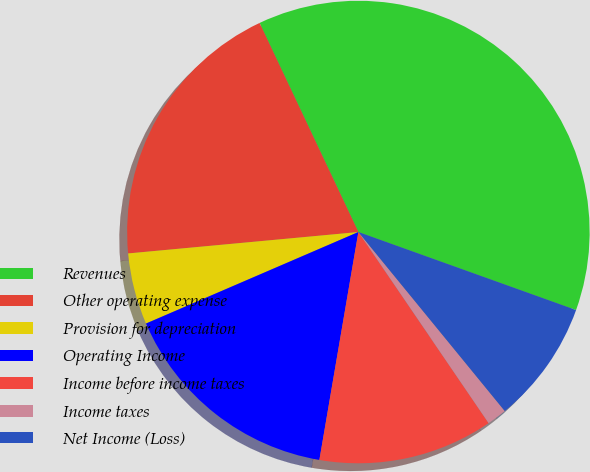Convert chart. <chart><loc_0><loc_0><loc_500><loc_500><pie_chart><fcel>Revenues<fcel>Other operating expense<fcel>Provision for depreciation<fcel>Operating Income<fcel>Income before income taxes<fcel>Income taxes<fcel>Net Income (Loss)<nl><fcel>37.51%<fcel>19.45%<fcel>5.0%<fcel>15.83%<fcel>12.22%<fcel>1.39%<fcel>8.61%<nl></chart> 